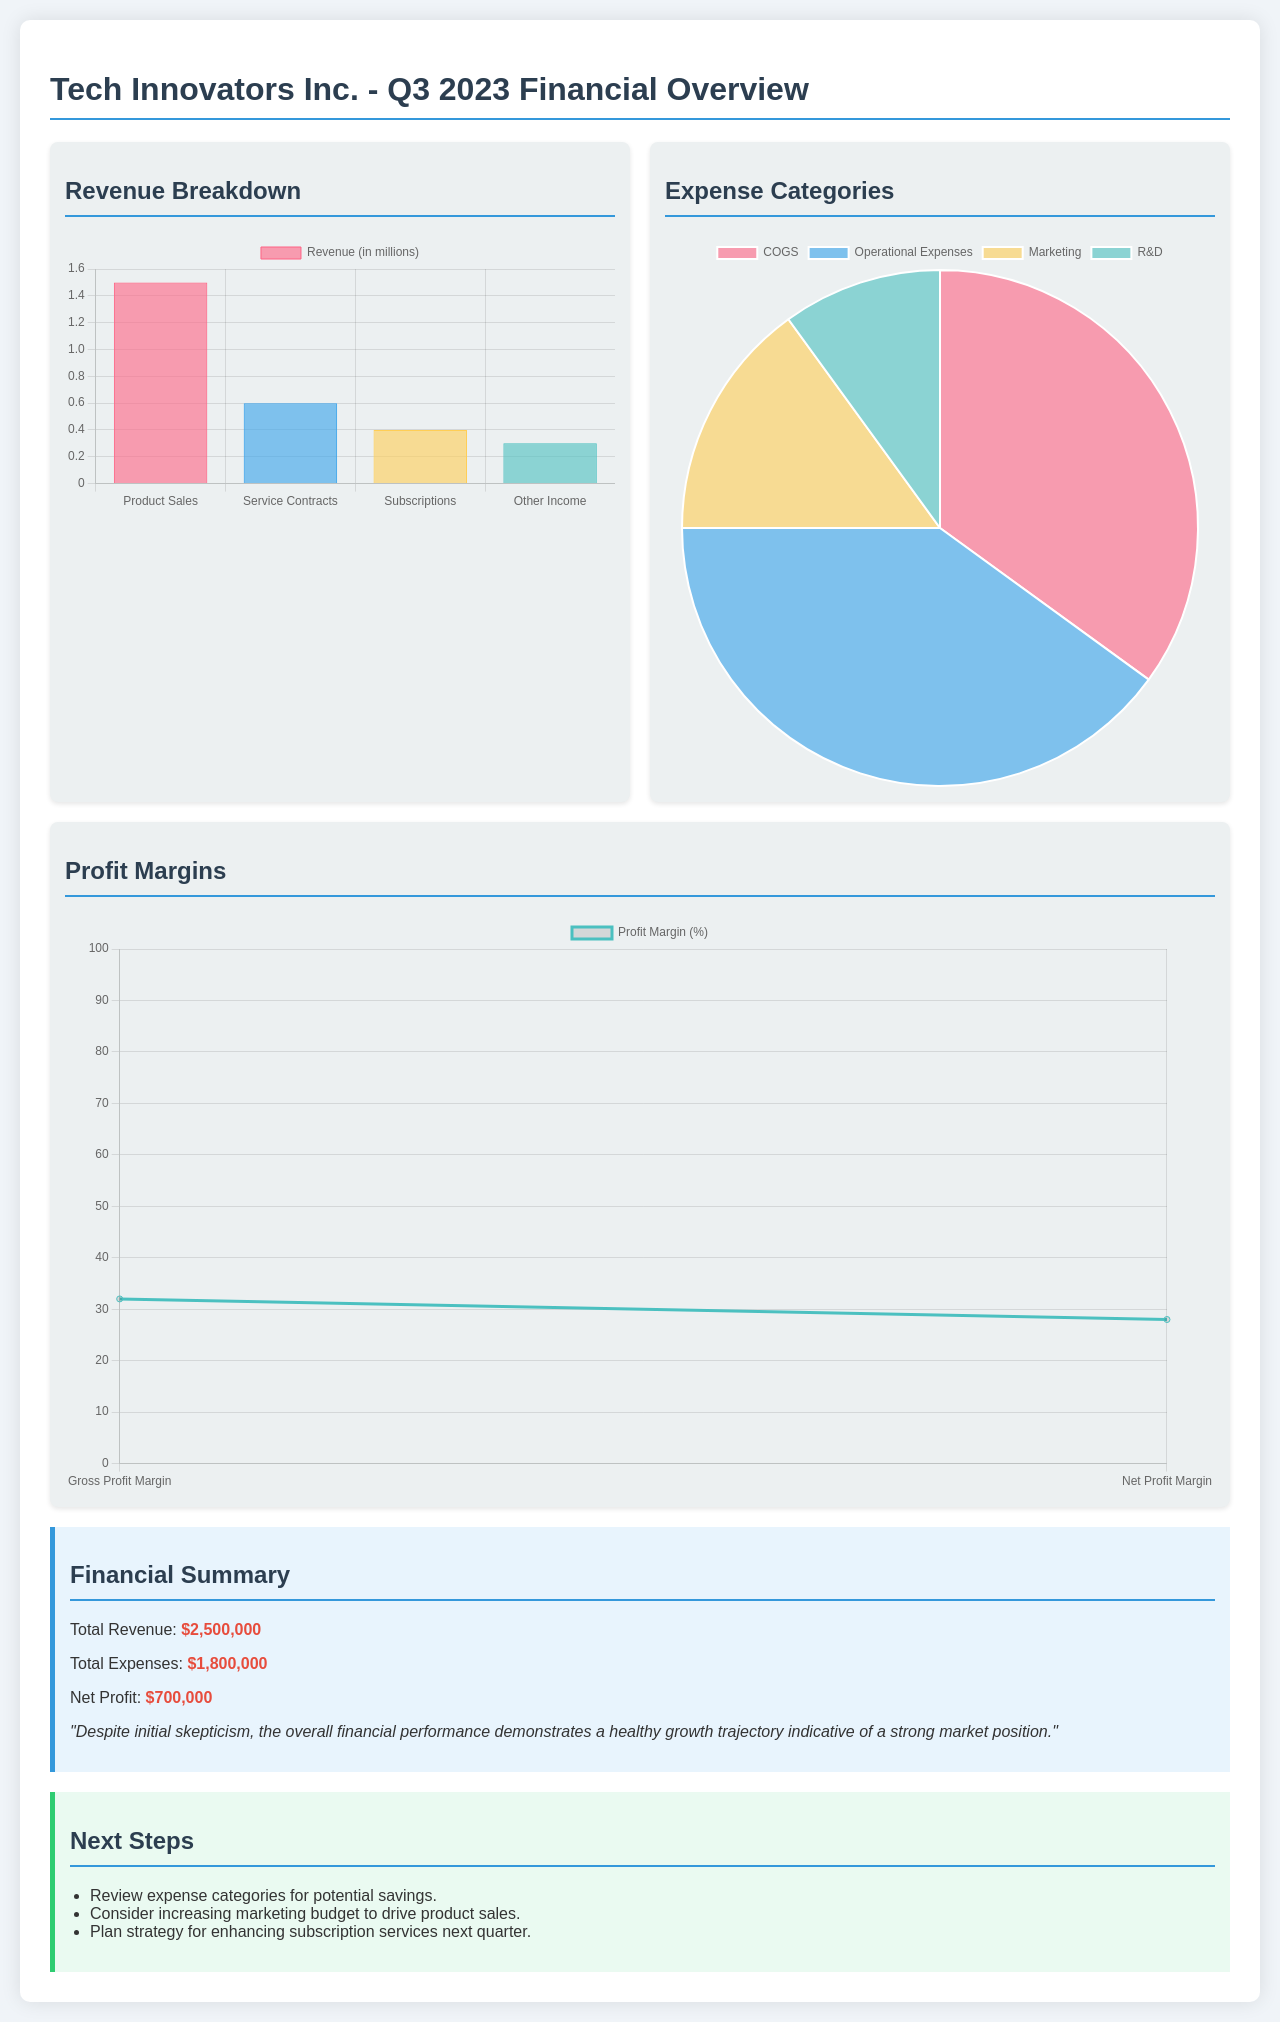What is the total revenue? The total revenue is specifically mentioned in the financial summary as $2,500,000.
Answer: $2,500,000 What are the total expenses? The total expenses are detailed in the financial summary and are listed as $1,800,000.
Answer: $1,800,000 What is the net profit? The document states that the net profit is $700,000.
Answer: $700,000 What category has the highest revenue? The revenue breakdown chart indicates that Product Sales generates the highest revenue at $1,500,000.
Answer: Product Sales What is the percentage of the Gross Profit Margin? According to the profit margin chart, the Gross Profit Margin is specified as 32 percent.
Answer: 32% What category has the largest expense? The expenses chart shows that COGS has the largest expense of $700,000.
Answer: COGS What is the total profit margin percentage? The document notes that the Net Profit Margin is 28 percent, representing the total profit margin.
Answer: 28% What are the colors used to represent Marketing Expenses? In the expenses chart, the color representing Marketing Expenses is shown as Yellow.
Answer: Yellow What is one of the next steps suggested? The document lists "Review expense categories for potential savings" as one of the next steps suggested.
Answer: Review expense categories for potential savings 